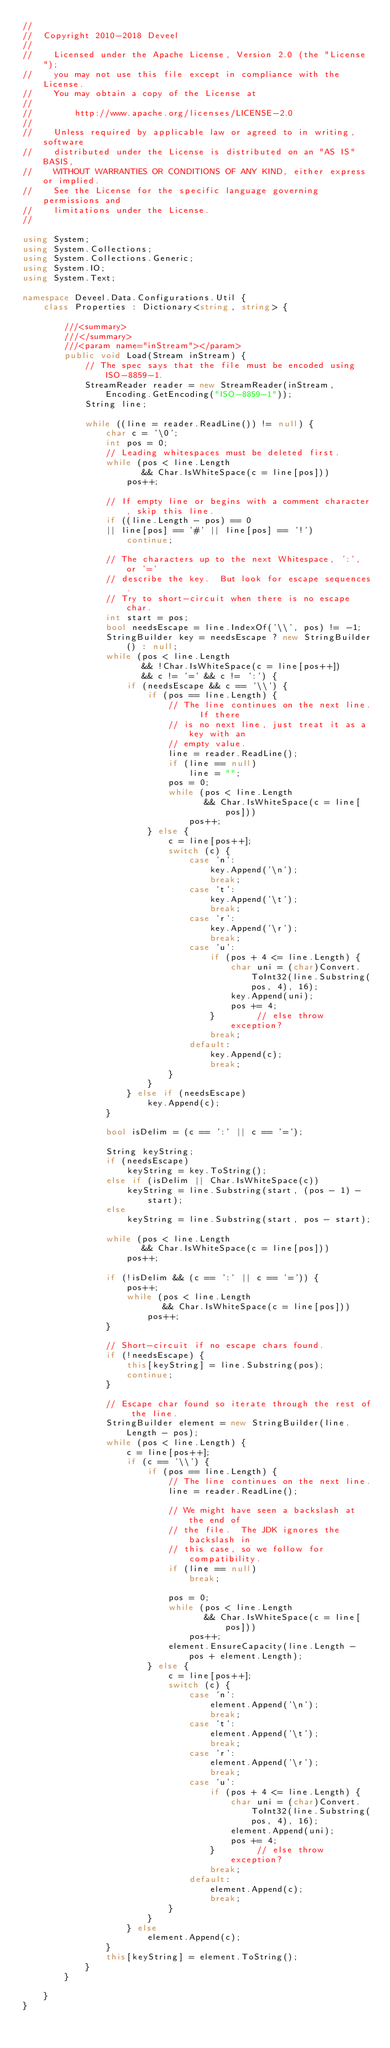Convert code to text. <code><loc_0><loc_0><loc_500><loc_500><_C#_>// 
//  Copyright 2010-2018 Deveel
// 
//    Licensed under the Apache License, Version 2.0 (the "License");
//    you may not use this file except in compliance with the License.
//    You may obtain a copy of the License at
// 
//        http://www.apache.org/licenses/LICENSE-2.0
// 
//    Unless required by applicable law or agreed to in writing, software
//    distributed under the License is distributed on an "AS IS" BASIS,
//    WITHOUT WARRANTIES OR CONDITIONS OF ANY KIND, either express or implied.
//    See the License for the specific language governing permissions and
//    limitations under the License.
//

using System;
using System.Collections;
using System.Collections.Generic;
using System.IO;
using System.Text;

namespace Deveel.Data.Configurations.Util {
	class Properties : Dictionary<string, string> {

		///<summary>
		///</summary>
		///<param name="inStream"></param>
		public void Load(Stream inStream) {
			// The spec says that the file must be encoded using ISO-8859-1.
			StreamReader reader = new StreamReader(inStream, Encoding.GetEncoding("ISO-8859-1"));
			String line;

			while ((line = reader.ReadLine()) != null) {
				char c = '\0';
				int pos = 0;
				// Leading whitespaces must be deleted first.
				while (pos < line.Length
					   && Char.IsWhiteSpace(c = line[pos]))
					pos++;

				// If empty line or begins with a comment character, skip this line.
				if ((line.Length - pos) == 0
				|| line[pos] == '#' || line[pos] == '!')
					continue;

				// The characters up to the next Whitespace, ':', or '='
				// describe the key.  But look for escape sequences.
				// Try to short-circuit when there is no escape char.
				int start = pos;
				bool needsEscape = line.IndexOf('\\', pos) != -1;
				StringBuilder key = needsEscape ? new StringBuilder() : null;
				while (pos < line.Length
					   && !Char.IsWhiteSpace(c = line[pos++])
					   && c != '=' && c != ':') {
					if (needsEscape && c == '\\') {
						if (pos == line.Length) {
							// The line continues on the next line.  If there
							// is no next line, just treat it as a key with an
							// empty value.
							line = reader.ReadLine();
							if (line == null)
								line = "";
							pos = 0;
							while (pos < line.Length
								   && Char.IsWhiteSpace(c = line[pos]))
								pos++;
						} else {
							c = line[pos++];
							switch (c) {
								case 'n':
									key.Append('\n');
									break;
								case 't':
									key.Append('\t');
									break;
								case 'r':
									key.Append('\r');
									break;
								case 'u':
									if (pos + 4 <= line.Length) {
										char uni = (char)Convert.ToInt32(line.Substring(pos, 4), 16);
										key.Append(uni);
										pos += 4;
									}        // else throw exception?
									break;
								default:
									key.Append(c);
									break;
							}
						}
					} else if (needsEscape)
						key.Append(c);
				}

				bool isDelim = (c == ':' || c == '=');

				String keyString;
				if (needsEscape)
					keyString = key.ToString();
				else if (isDelim || Char.IsWhiteSpace(c))
					keyString = line.Substring(start, (pos - 1) - start);
				else
					keyString = line.Substring(start, pos - start);

				while (pos < line.Length
					   && Char.IsWhiteSpace(c = line[pos]))
					pos++;

				if (!isDelim && (c == ':' || c == '=')) {
					pos++;
					while (pos < line.Length
						   && Char.IsWhiteSpace(c = line[pos]))
						pos++;
				}

				// Short-circuit if no escape chars found.
				if (!needsEscape) {
					this[keyString] = line.Substring(pos);
					continue;
				}

				// Escape char found so iterate through the rest of the line.
				StringBuilder element = new StringBuilder(line.Length - pos);
				while (pos < line.Length) {
					c = line[pos++];
					if (c == '\\') {
						if (pos == line.Length) {
							// The line continues on the next line.
							line = reader.ReadLine();

							// We might have seen a backslash at the end of
							// the file.  The JDK ignores the backslash in
							// this case, so we follow for compatibility.
							if (line == null)
								break;

							pos = 0;
							while (pos < line.Length
								   && Char.IsWhiteSpace(c = line[pos]))
								pos++;
							element.EnsureCapacity(line.Length - pos + element.Length);
						} else {
							c = line[pos++];
							switch (c) {
								case 'n':
									element.Append('\n');
									break;
								case 't':
									element.Append('\t');
									break;
								case 'r':
									element.Append('\r');
									break;
								case 'u':
									if (pos + 4 <= line.Length) {
										char uni = (char)Convert.ToInt32(line.Substring(pos, 4), 16);
										element.Append(uni);
										pos += 4;
									}        // else throw exception?
									break;
								default:
									element.Append(c);
									break;
							}
						}
					} else
						element.Append(c);
				}
				this[keyString] = element.ToString();
			}
		}

	}
}</code> 